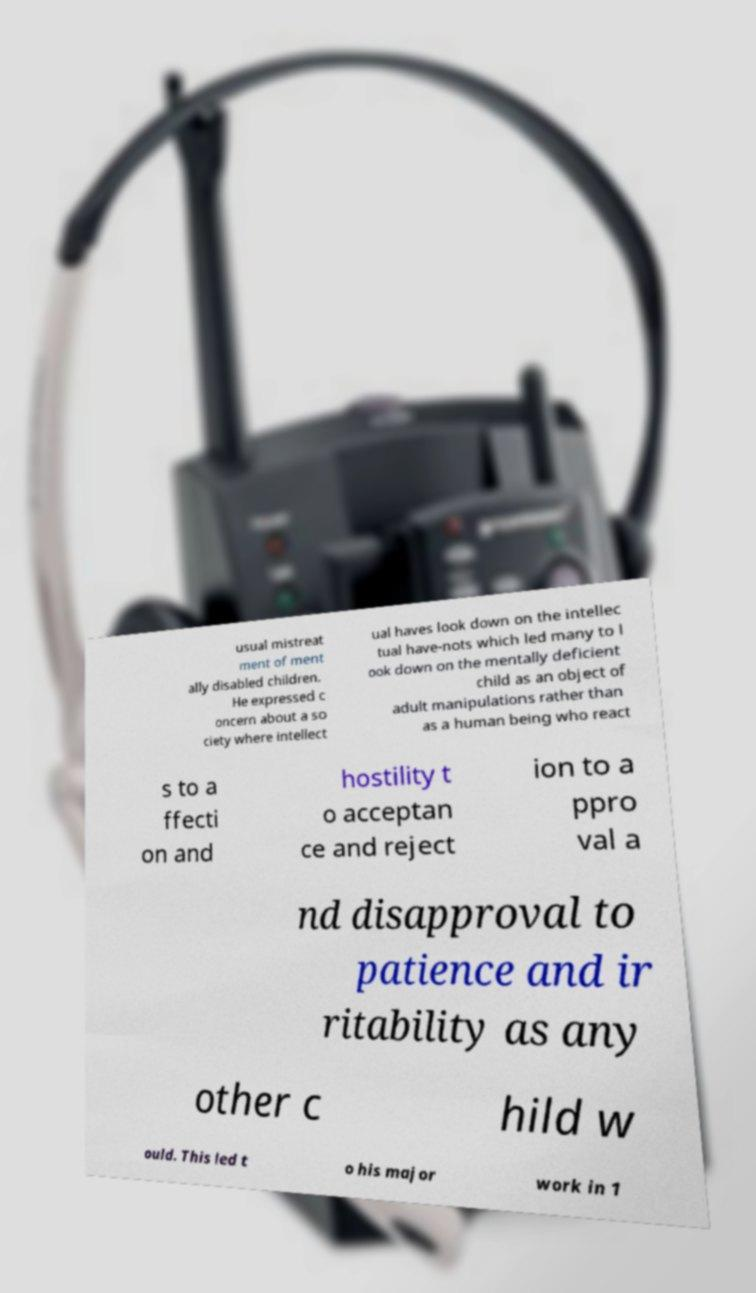Please identify and transcribe the text found in this image. usual mistreat ment of ment ally disabled children. He expressed c oncern about a so ciety where intellect ual haves look down on the intellec tual have-nots which led many to l ook down on the mentally deficient child as an object of adult manipulations rather than as a human being who react s to a ffecti on and hostility t o acceptan ce and reject ion to a ppro val a nd disapproval to patience and ir ritability as any other c hild w ould. This led t o his major work in 1 